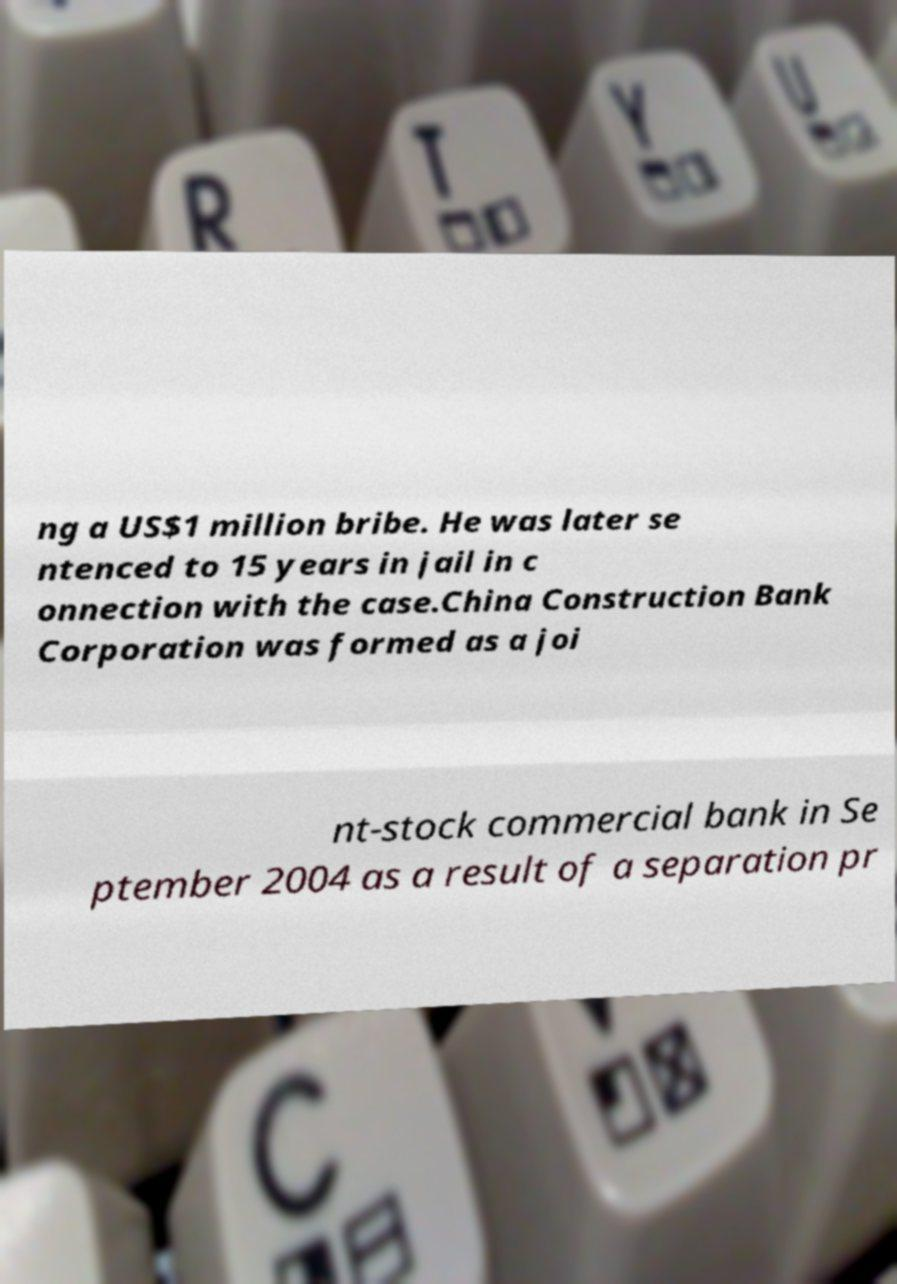Could you extract and type out the text from this image? ng a US$1 million bribe. He was later se ntenced to 15 years in jail in c onnection with the case.China Construction Bank Corporation was formed as a joi nt-stock commercial bank in Se ptember 2004 as a result of a separation pr 